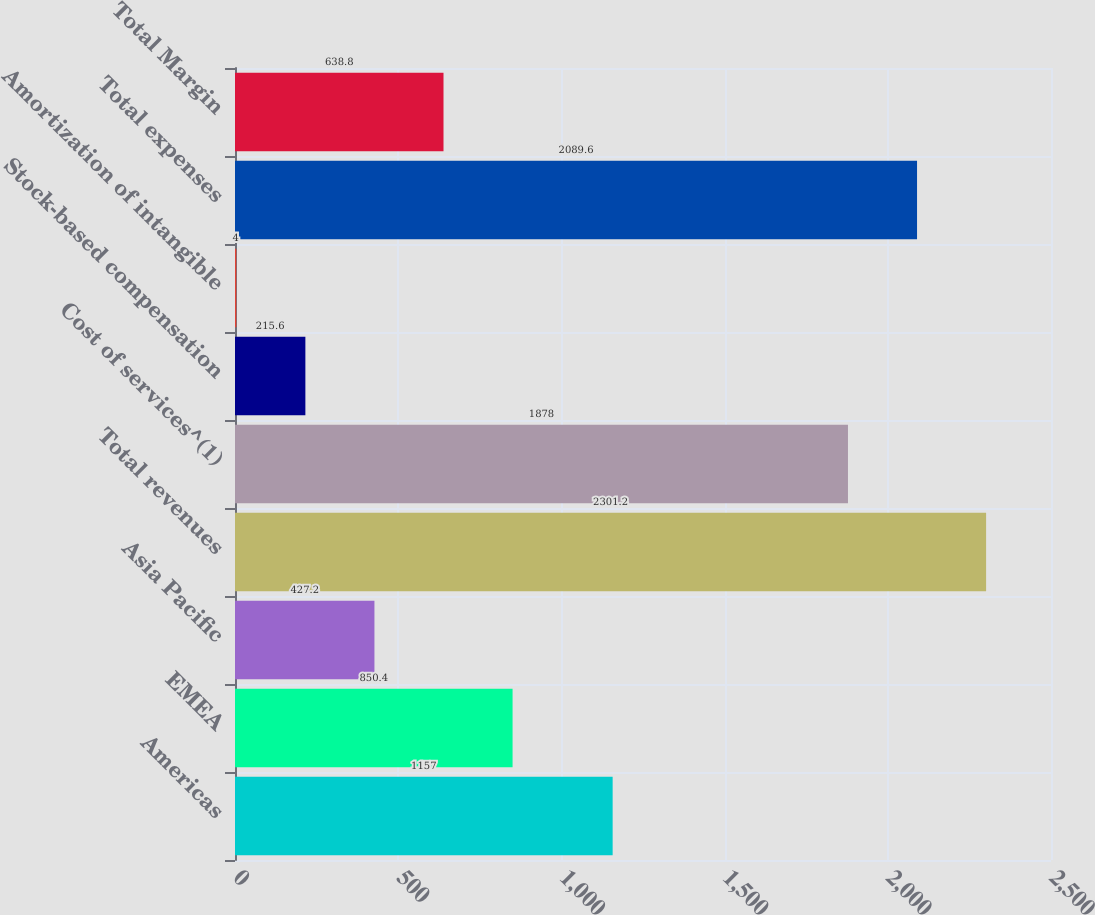<chart> <loc_0><loc_0><loc_500><loc_500><bar_chart><fcel>Americas<fcel>EMEA<fcel>Asia Pacific<fcel>Total revenues<fcel>Cost of services^(1)<fcel>Stock-based compensation<fcel>Amortization of intangible<fcel>Total expenses<fcel>Total Margin<nl><fcel>1157<fcel>850.4<fcel>427.2<fcel>2301.2<fcel>1878<fcel>215.6<fcel>4<fcel>2089.6<fcel>638.8<nl></chart> 